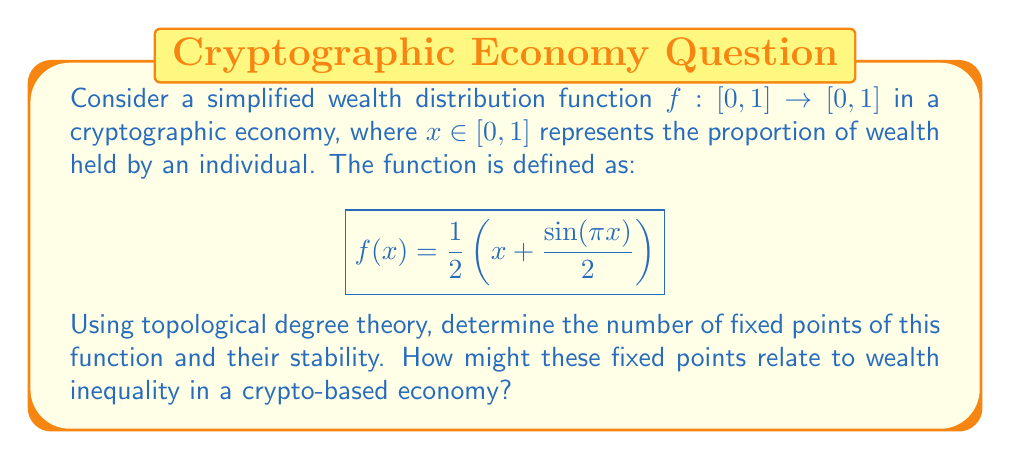Help me with this question. To solve this problem, we'll follow these steps:

1) First, we need to find the fixed points of the function. Fixed points occur when $f(x) = x$.

2) We can rewrite the equation as $g(x) = f(x) - x = 0$:

   $$g(x) = \frac{1}{2}\left(x + \frac{\sin(\pi x)}{2}\right) - x = \frac{\sin(\pi x)}{4} - \frac{x}{2}$$

3) To apply topological degree theory, we need to examine the behavior of $g(x)$ at the endpoints of $[0,1]$:

   At $x = 0$: $g(0) = 0$
   At $x = 1$: $g(1) = -\frac{1}{2}$

   The function changes sign from 0 to negative, indicating an odd degree.

4) The degree of $g(x)$ on $[0,1]$ is therefore 1, which means there is at least one fixed point.

5) To find the exact number and location of fixed points, we can analyze $g'(x)$:

   $$g'(x) = \frac{\pi}{4}\cos(\pi x) - \frac{1}{2}$$

6) Setting $g'(x) = 0$:

   $$\frac{\pi}{4}\cos(\pi x) = \frac{1}{2}$$
   $$\cos(\pi x) = \frac{2}{\pi}$$

   This equation has two solutions in $[0,1]$: $x \approx 0.2206$ and $x \approx 0.7794$.

7) These critical points, along with the endpoints, divide $[0,1]$ into three intervals. Evaluating $g(x)$ at these points:

   $g(0) = 0$
   $g(0.2206) \approx 0.0559$ (positive)
   $g(0.7794) \approx -0.0559$ (negative)
   $g(1) = -0.5$

8) This confirms three fixed points: one at $x=0$, and one each in $(0, 0.2206)$ and $(0.7794, 1)$.

9) To determine stability, we examine $f'(x)$ at each fixed point:
   
   $$f'(x) = \frac{1}{2} + \frac{\pi}{4}\cos(\pi x)$$

   If $|f'(x)| < 1$, the fixed point is stable; if $|f'(x)| > 1$, it's unstable.

   At $x=0$: $f'(0) = \frac{1}{2} + \frac{\pi}{4} \approx 1.2854 > 1$ (unstable)
   At the middle fixed point: $f'(x) < 1$ (stable)
   At the upper fixed point: $f'(x) > 1$ (unstable)

In the context of a crypto-based economy, these fixed points represent potential equilibrium states of wealth distribution. The stable fixed point suggests a moderate level of wealth concentration, while the unstable fixed points at the extremes indicate potential for both extreme equality (near 0) and extreme inequality (near 1), but these states are less likely to persist.
Answer: The wealth distribution function has three fixed points: one at 0, one between 0 and 0.2206, and one between 0.7794 and 1. The middle fixed point is stable, while the other two are unstable. This suggests a tendency towards a moderate level of wealth concentration in the crypto-based economy, with potential for short-lived periods of extreme equality or inequality. 